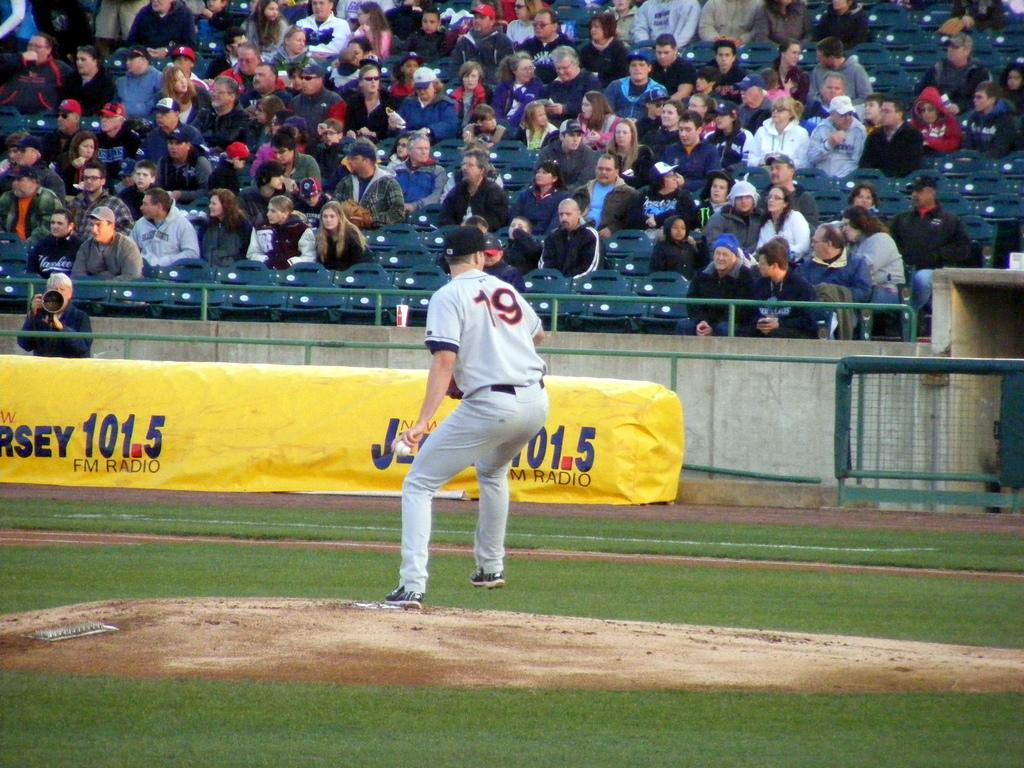<image>
Render a clear and concise summary of the photo. A baseball player with the number 19 on his jersey is standing on the mound. 